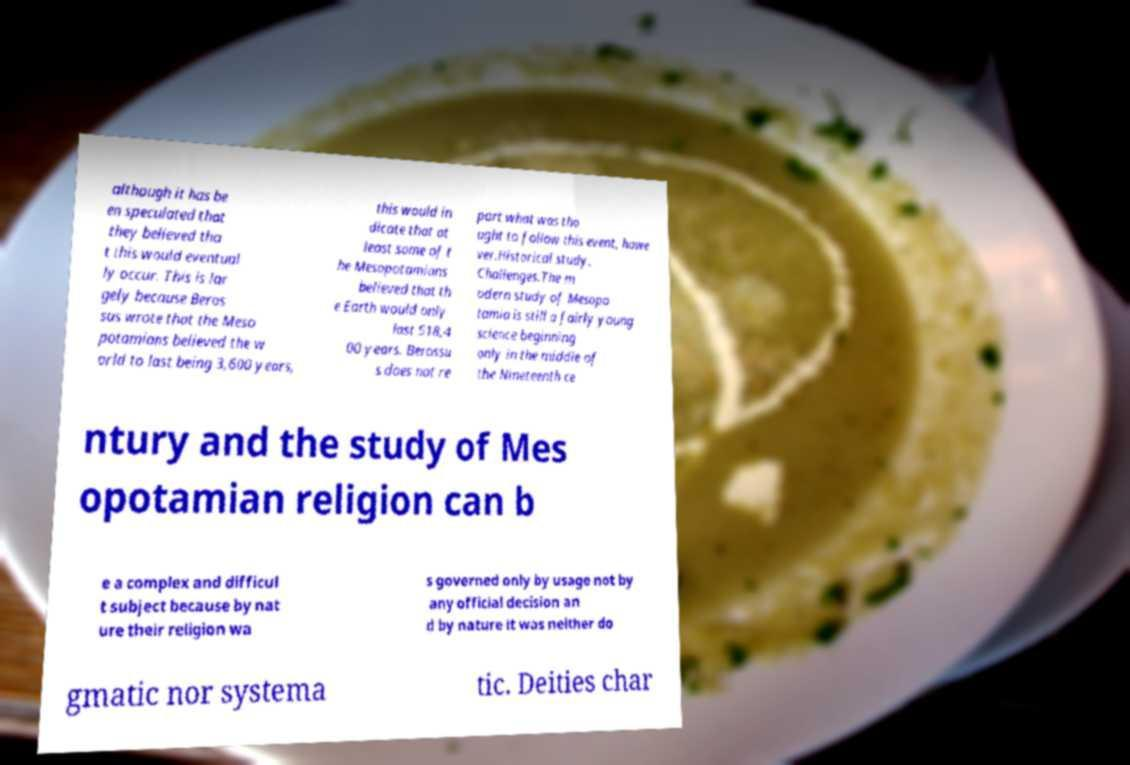There's text embedded in this image that I need extracted. Can you transcribe it verbatim? although it has be en speculated that they believed tha t this would eventual ly occur. This is lar gely because Beros sus wrote that the Meso potamians believed the w orld to last being 3,600 years, this would in dicate that at least some of t he Mesopotamians believed that th e Earth would only last 518,4 00 years. Berossu s does not re port what was tho ught to follow this event, howe ver.Historical study. Challenges.The m odern study of Mesopo tamia is still a fairly young science beginning only in the middle of the Nineteenth ce ntury and the study of Mes opotamian religion can b e a complex and difficul t subject because by nat ure their religion wa s governed only by usage not by any official decision an d by nature it was neither do gmatic nor systema tic. Deities char 